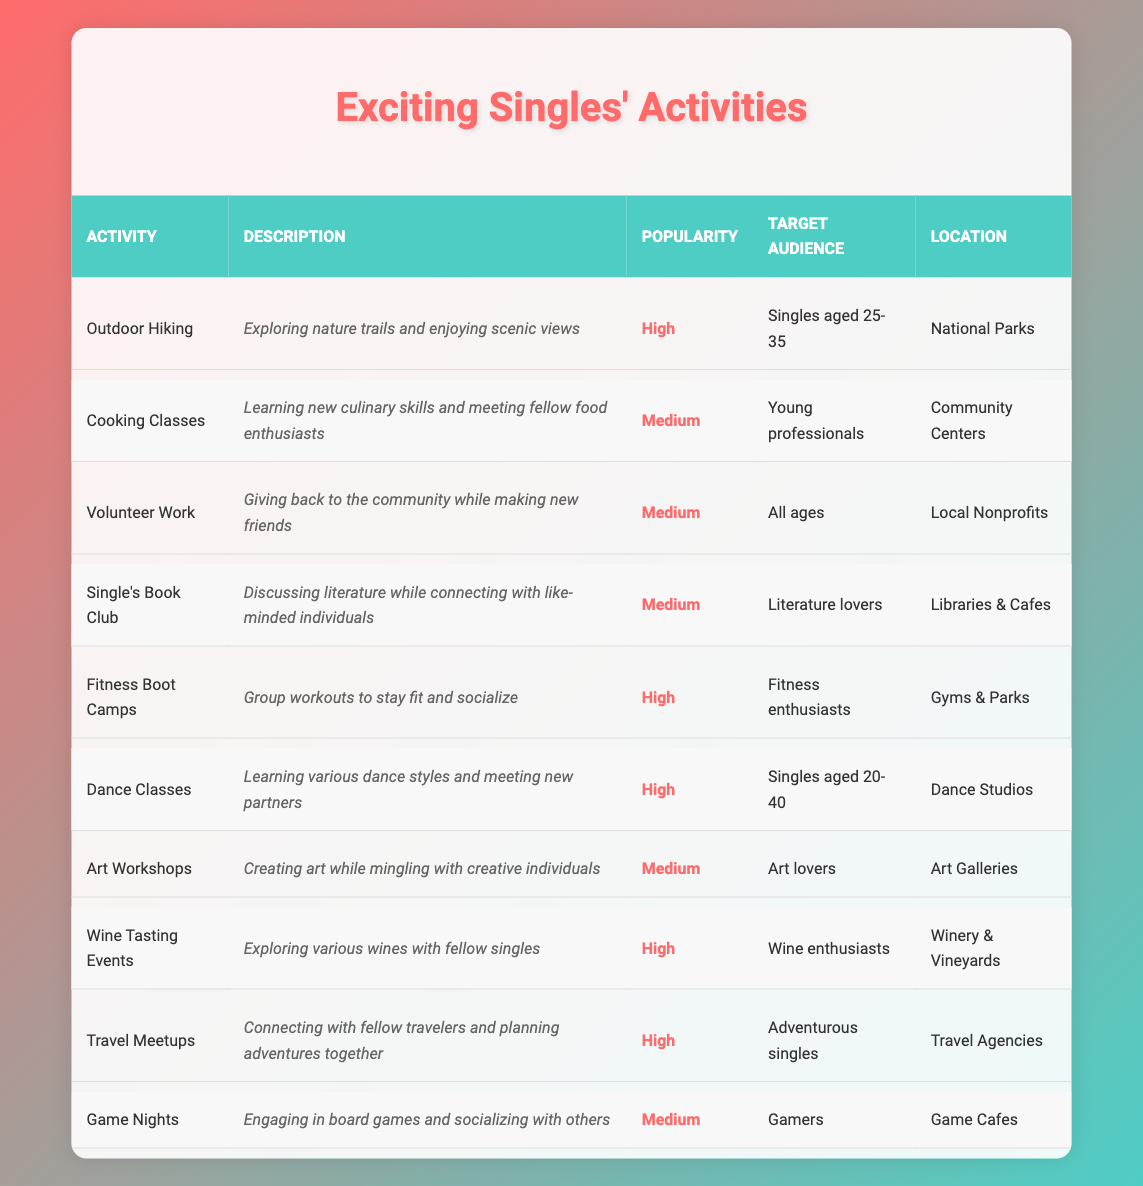What is the most popular hobby listed for singles? The table lists "Outdoor Hiking," "Fitness Boot Camps," "Dance Classes," "Wine Tasting Events," and "Travel Meetups" as high in popularity. Among these, any of them could be considered the most popular, but since all are high, there isn't a single standout answer.
Answer: Multiple activities share high popularity Which activities target wine enthusiasts? According to the table, the "Wine Tasting Events" activity specifically targets wine enthusiasts.
Answer: Wine Tasting Events How many activities are listed as medium in popularity? In the table, "Cooking Classes," "Volunteer Work," "Single's Book Club," "Art Workshops," and "Game Nights" are marked as medium in popularity, totaling five activities.
Answer: Five activities Are there any activities for adventurous singles? Yes, the table indicates that "Travel Meetups" is specifically aimed at adventurous singles.
Answer: Yes What is the average popularity rating across all activities? The average popularity cannot be numerically calculated as it's categorical (high, medium). However, the majority fall under high and medium, indicating a generally positive interest among all activities.
Answer: Cannot calculate average Which activity is suitable for all ages? The "Volunteer Work" activity is noted to target all ages, making it suitable for a diverse audience.
Answer: Volunteer Work Are there more high popularity activities or medium popularity activities? There are six activities (Outdoor Hiking, Fitness Boot Camps, Dance Classes, Wine Tasting Events, Travel Meetups) listed as high in popularity, while there are four activities (Cooking Classes, Volunteer Work, Single's Book Club, Art Workshops, Game Nights) with medium popularity. Therefore, there are more high popularity activities.
Answer: More high popularity activities What is the most targeted age group for the "Dance Classes"? The "Dance Classes" primarily target singles aged 20-40, according to the table.
Answer: Singles aged 20-40 How many activities involve socializing through fitness? The table includes "Fitness Boot Camps," which involves group workouts and socializing, indicating one activity focused on socializing through fitness.
Answer: One activity Which location type is common for both "Single's Book Club" and "Cooking Classes"? Both "Single's Book Club" and "Cooking Classes" are located at community-centric places: "Libraries & Cafes" for the book club and "Community Centers" for cooking classes, indicating no common location type among them.
Answer: No common location type 